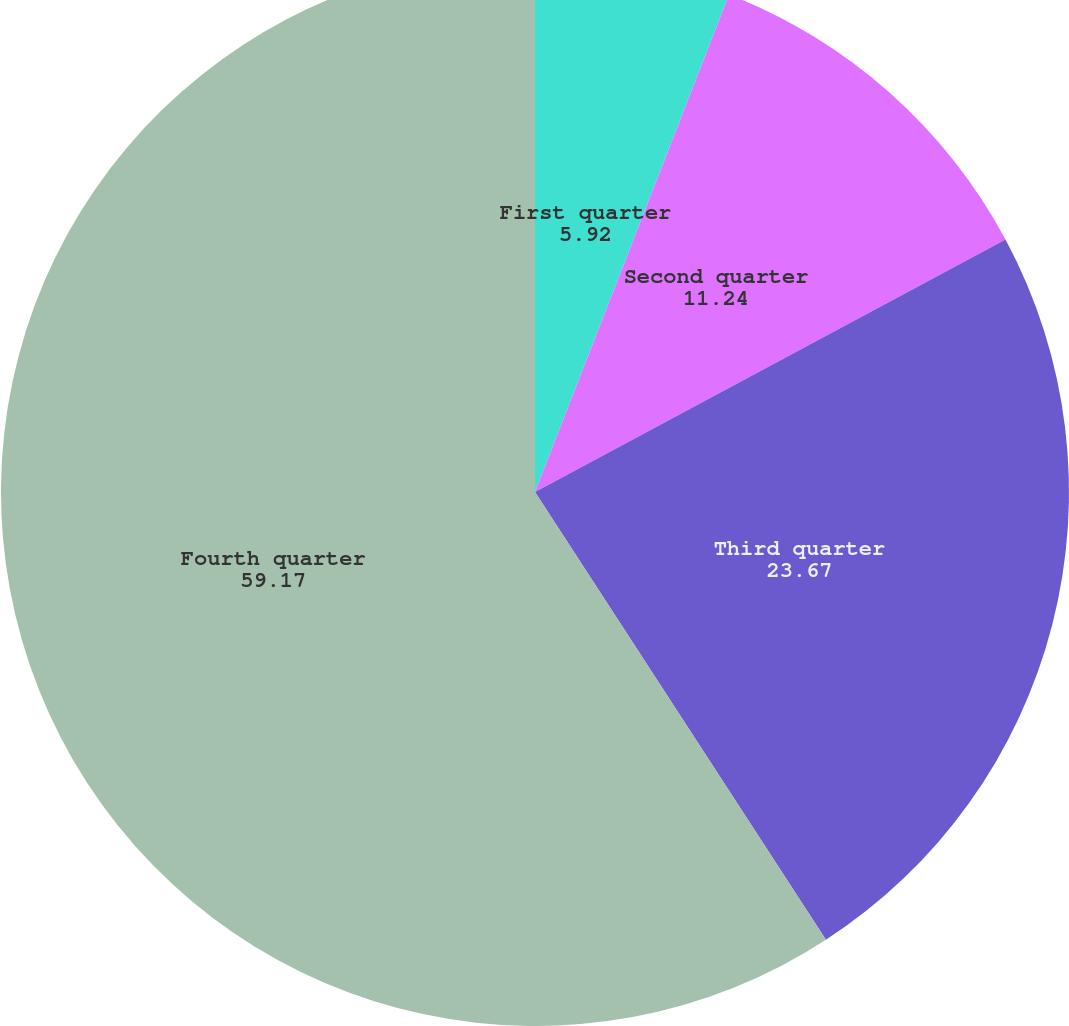<chart> <loc_0><loc_0><loc_500><loc_500><pie_chart><fcel>First quarter<fcel>Second quarter<fcel>Third quarter<fcel>Fourth quarter<nl><fcel>5.92%<fcel>11.24%<fcel>23.67%<fcel>59.17%<nl></chart> 